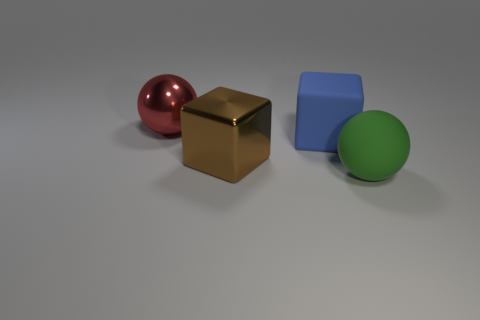Is the material of the ball that is behind the blue rubber thing the same as the large ball right of the red object?
Your answer should be very brief. No. Is the number of big green things that are behind the green matte ball the same as the number of brown objects that are behind the big brown metal cube?
Make the answer very short. Yes. What number of green things are the same material as the large blue cube?
Offer a terse response. 1. There is a brown shiny thing that is on the left side of the large ball in front of the big brown thing; what size is it?
Make the answer very short. Large. There is a shiny object in front of the red metal thing; is it the same shape as the large matte object behind the green thing?
Your response must be concise. Yes. Are there an equal number of big rubber spheres that are on the right side of the large green rubber thing and purple shiny cylinders?
Make the answer very short. Yes. The shiny thing that is the same shape as the green rubber object is what color?
Provide a succinct answer. Red. Is the material of the big sphere that is on the left side of the brown block the same as the large brown cube?
Ensure brevity in your answer.  Yes. What number of large objects are brown metal objects or balls?
Offer a very short reply. 3. The brown object is what size?
Provide a short and direct response. Large. 